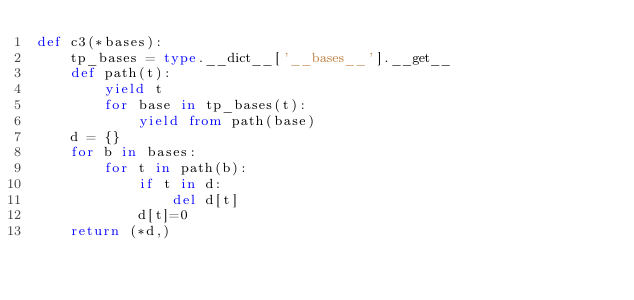<code> <loc_0><loc_0><loc_500><loc_500><_Python_>def c3(*bases):
    tp_bases = type.__dict__['__bases__'].__get__
    def path(t):
        yield t
        for base in tp_bases(t):
            yield from path(base)
    d = {}
    for b in bases:
        for t in path(b):
            if t in d:
                del d[t]
            d[t]=0
    return (*d,)
</code> 